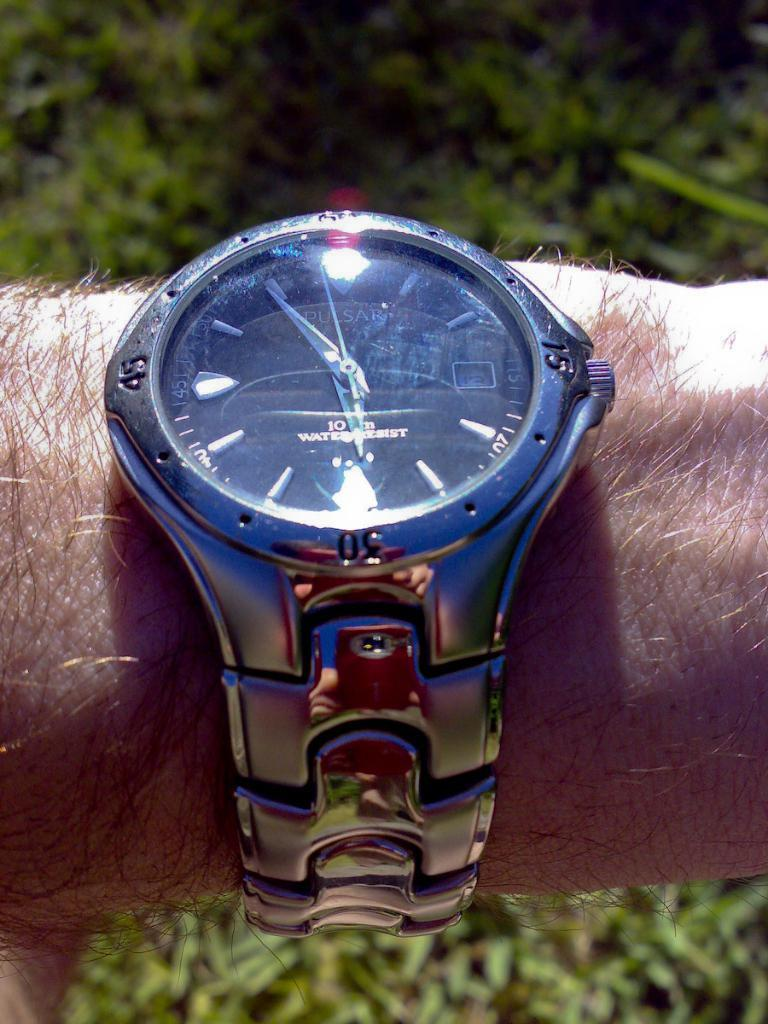Provide a one-sentence caption for the provided image. A man has a Pulsar watch on his wrist. 